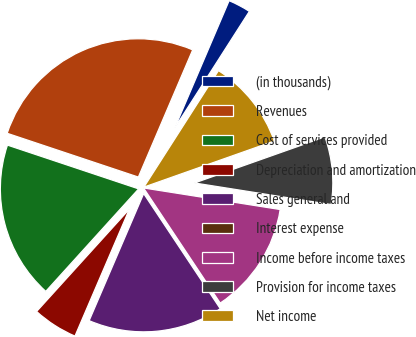Convert chart. <chart><loc_0><loc_0><loc_500><loc_500><pie_chart><fcel>(in thousands)<fcel>Revenues<fcel>Cost of services provided<fcel>Depreciation and amortization<fcel>Sales general and<fcel>Interest expense<fcel>Income before income taxes<fcel>Provision for income taxes<fcel>Net income<nl><fcel>2.64%<fcel>26.3%<fcel>18.41%<fcel>5.27%<fcel>15.79%<fcel>0.01%<fcel>13.16%<fcel>7.9%<fcel>10.53%<nl></chart> 